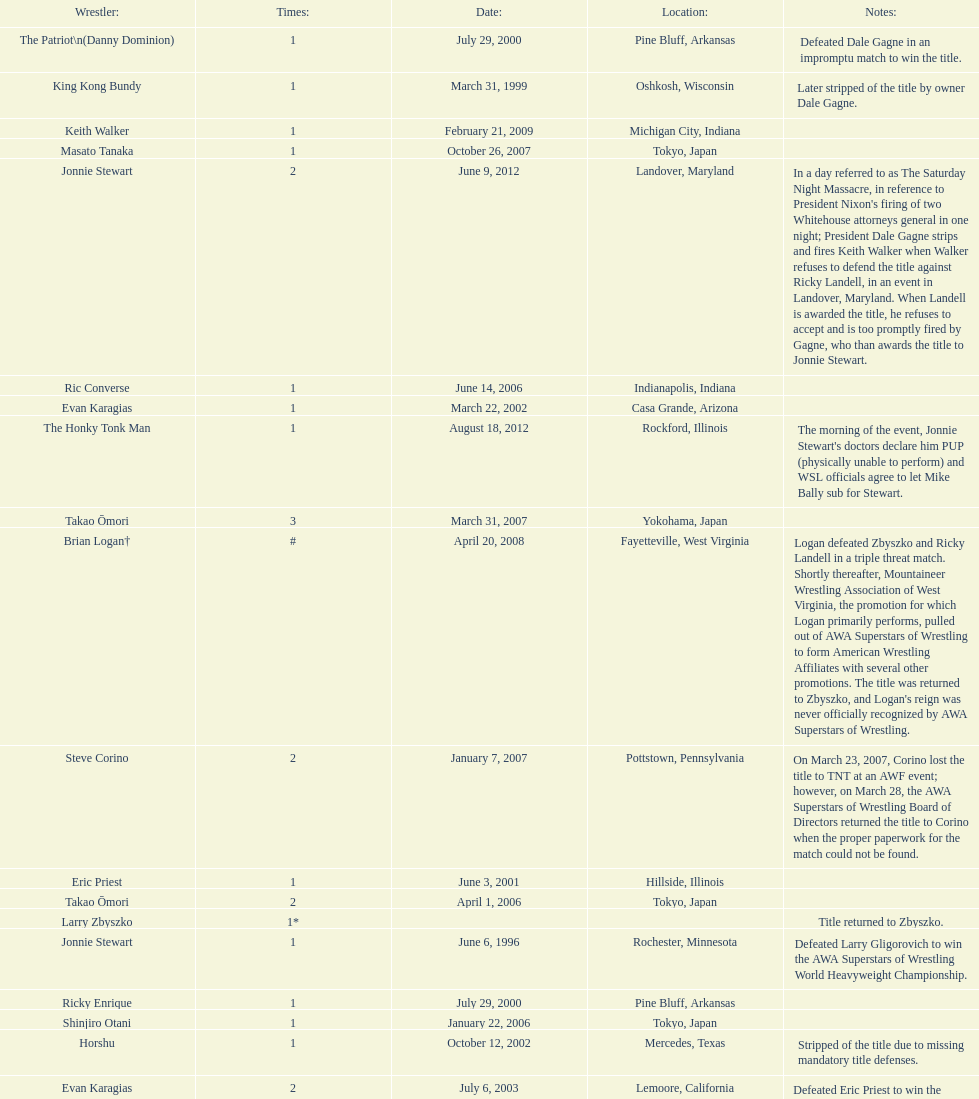When did steve corino win his first wsl title? June 11, 2005. 